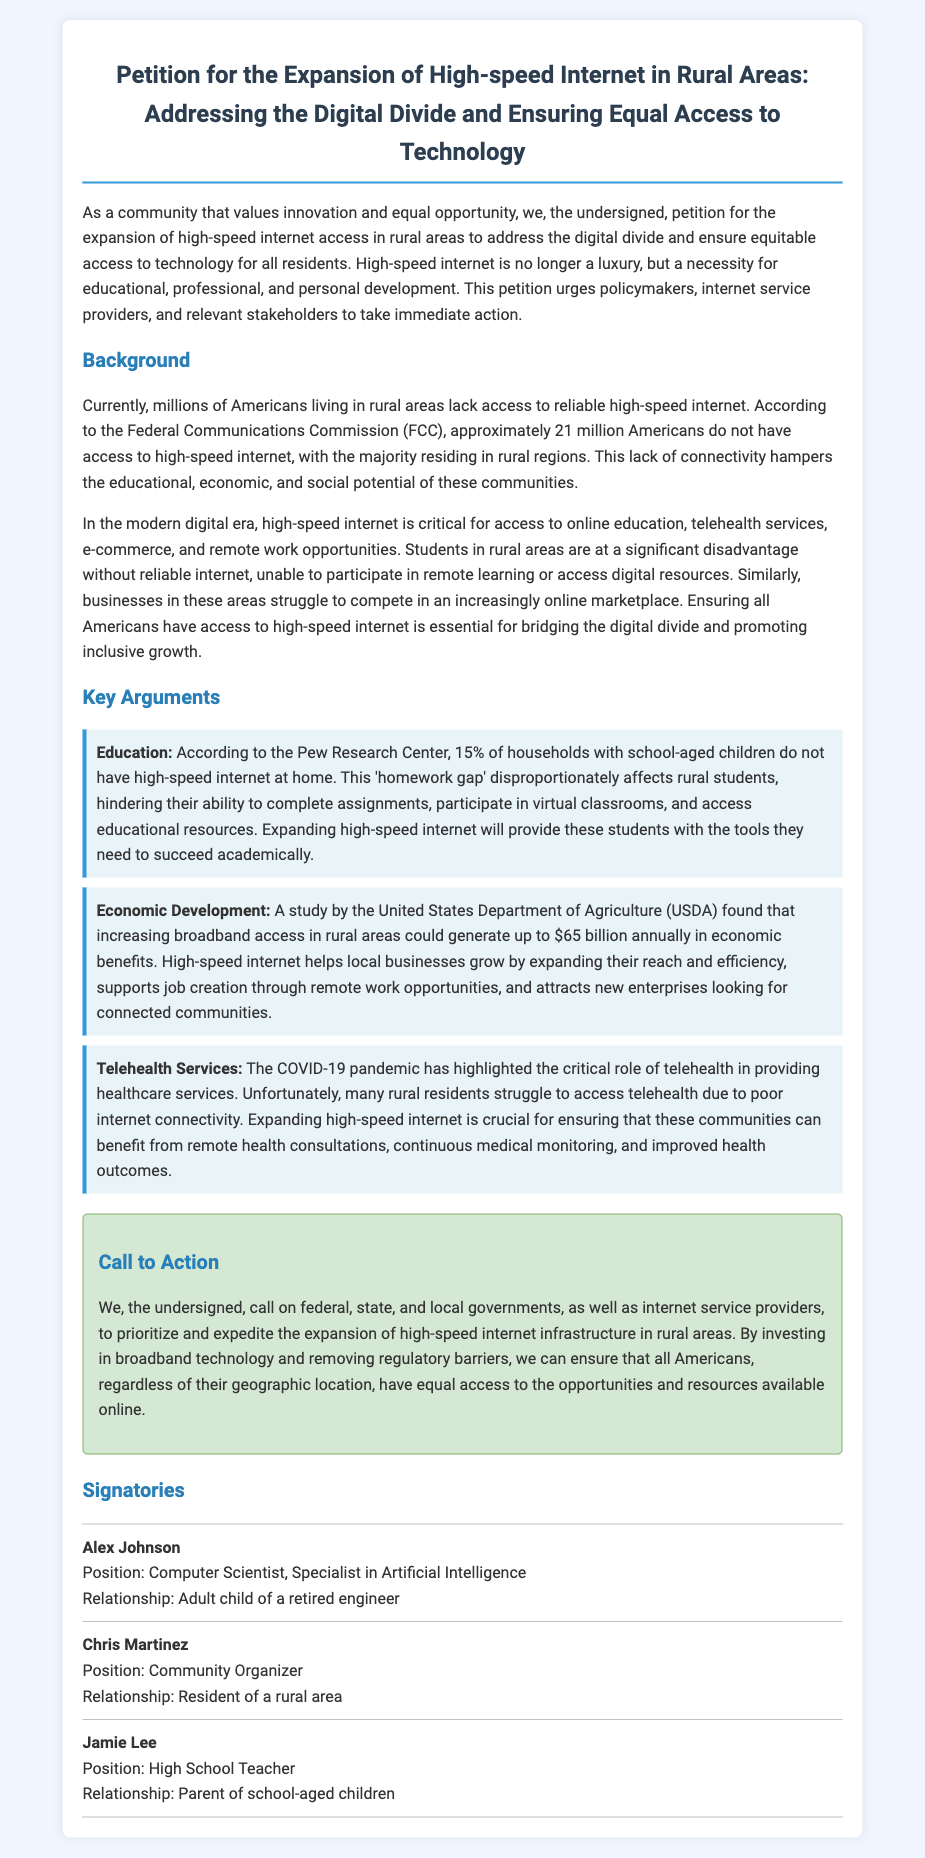What is the title of the petition? The title of the petition is stated prominently at the top of the document.
Answer: Petition for the Expansion of High-speed Internet in Rural Areas: Addressing the Digital Divide and Ensuring Equal Access to Technology According to the FCC, how many Americans lack access to high-speed internet? This statistic is mentioned in the background section of the document.
Answer: Approximately 21 million Americans What percentage of households with school-aged children lack high-speed internet? This figure is provided in the key arguments section under education.
Answer: 15% What is one major benefit of increasing broadband access in rural areas? The economic development section lists potential benefits that derive from expanded access.
Answer: Up to $65 billion annually What role has COVID-19 played according to the petition? The document specifies a particular impact of the pandemic in the telehealth services argument.
Answer: Highlighted the critical role of telehealth Who is the first signatory listed in the petition? The signatory section contains names of individuals who support the petition, listed in order.
Answer: Alex Johnson What is the call to action directed toward? The call to action section specifies the intended audience for the petition.
Answer: Federal, state, and local governments, as well as internet service providers What profession does Jamie Lee hold? Jamie Lee's profession is stated within the signatories section.
Answer: High School Teacher 